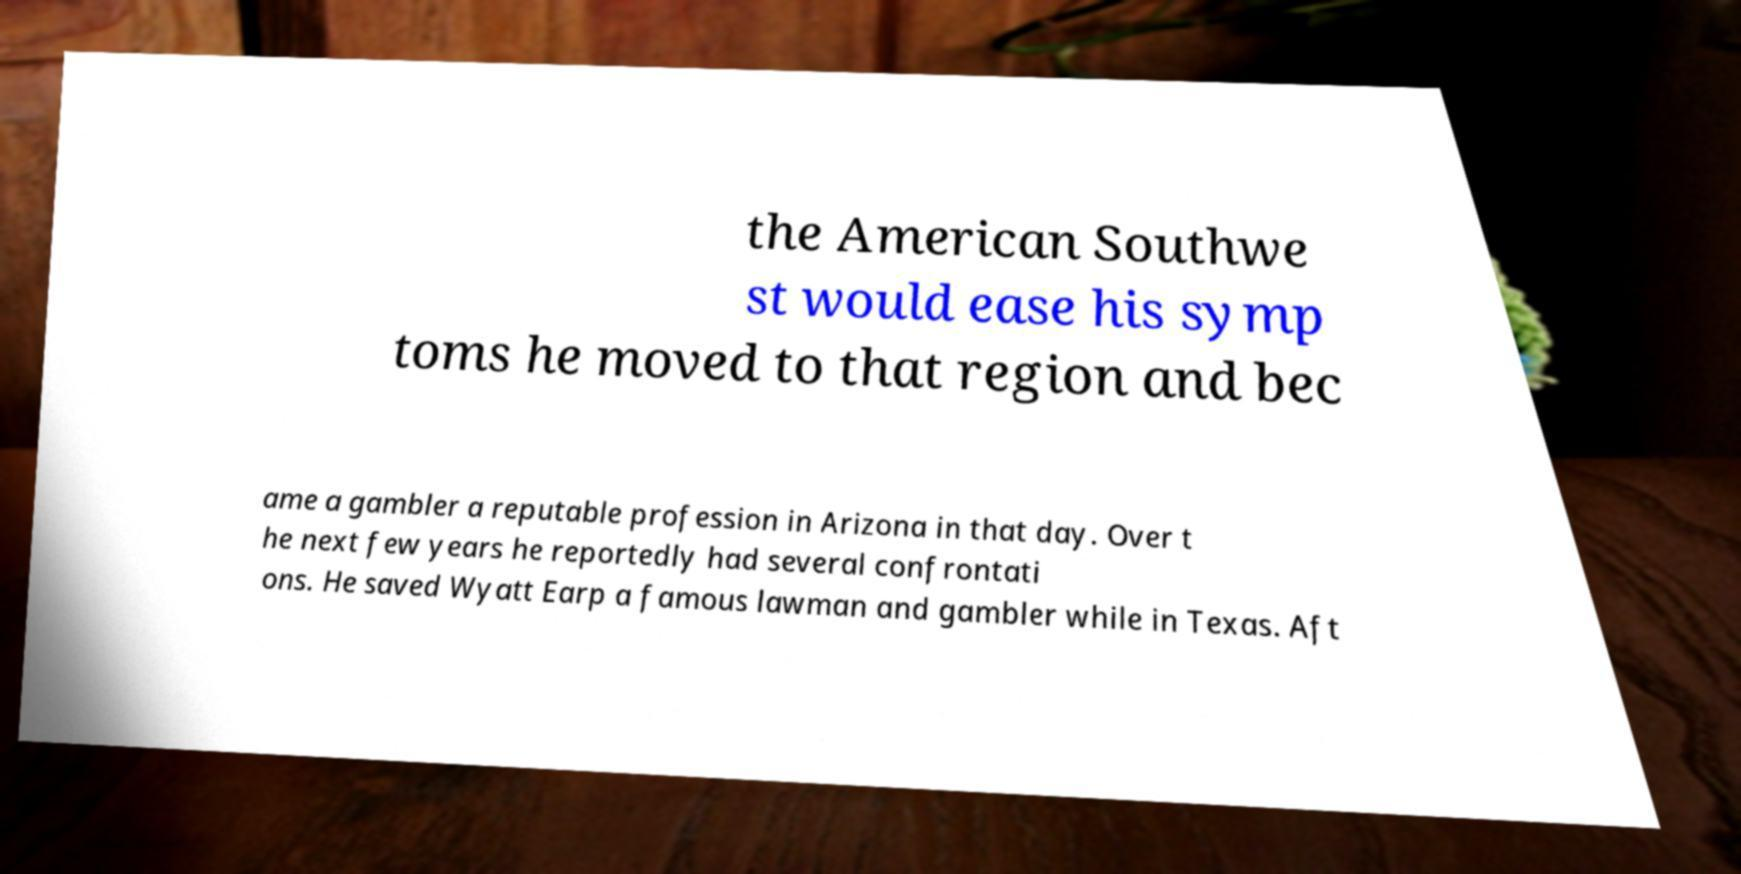Can you read and provide the text displayed in the image?This photo seems to have some interesting text. Can you extract and type it out for me? the American Southwe st would ease his symp toms he moved to that region and bec ame a gambler a reputable profession in Arizona in that day. Over t he next few years he reportedly had several confrontati ons. He saved Wyatt Earp a famous lawman and gambler while in Texas. Aft 